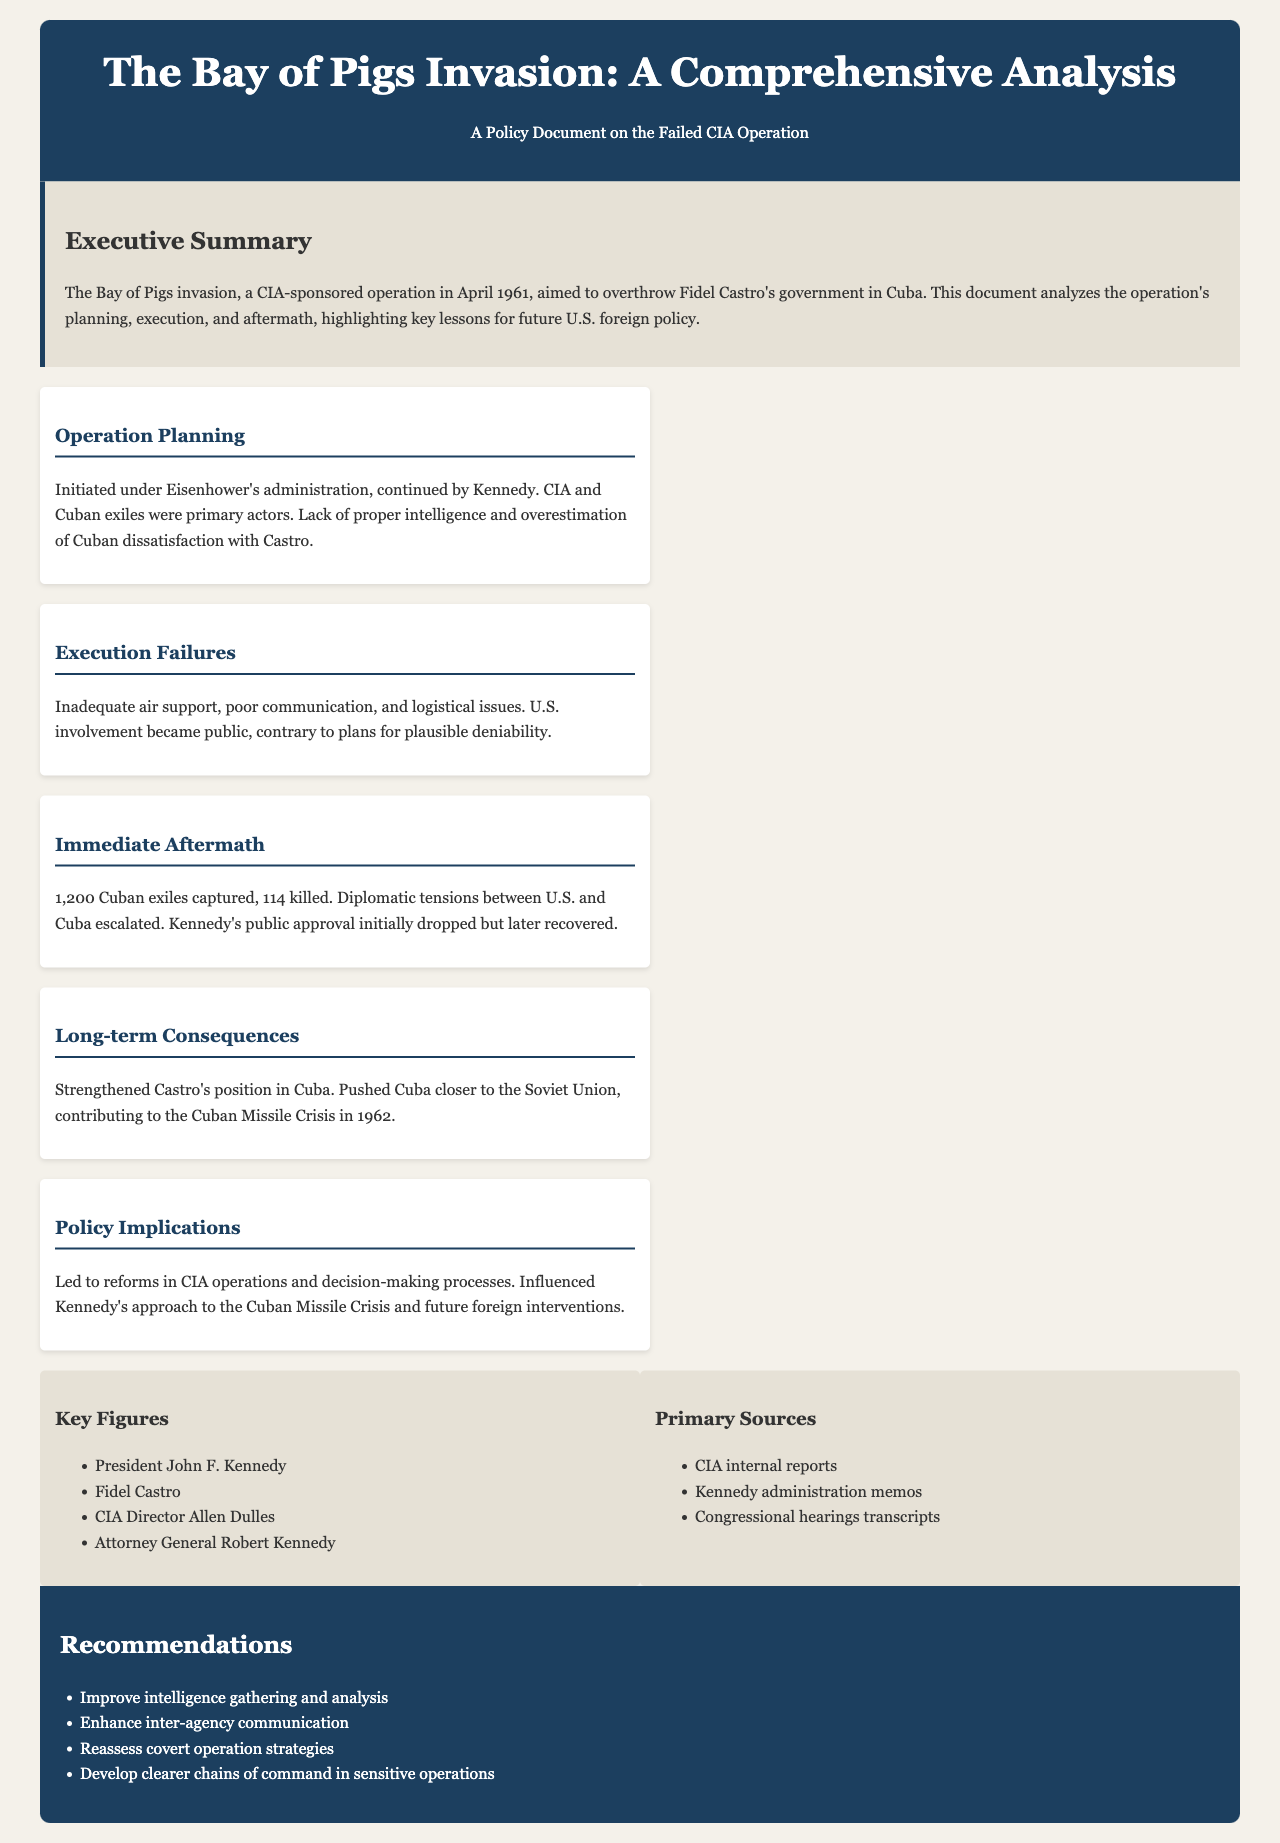What was the objective of the Bay of Pigs invasion? The objective was to overthrow Fidel Castro's government in Cuba.
Answer: Overthrow Fidel Castro's government Who were the primary actors in the operation planning? The primary actors were the CIA and Cuban exiles.
Answer: CIA and Cuban exiles What was the initial fate of the Cuban exiles who participated in the invasion? The fate of the Cuban exiles included 1,200 captured and 114 killed.
Answer: 1,200 captured, 114 killed What significant diplomatic outcome followed the invasion? The significant outcome was escalation of diplomatic tensions between U.S. and Cuba.
Answer: Escalation of diplomatic tensions Which year did the Bay of Pigs invasion take place? The year was April 1961.
Answer: April 1961 What was one of the long-term consequences of the operation? One consequence was strengthening Castro's position in Cuba.
Answer: Strengthening Castro's position Which document section discusses key lessons for future U.S. foreign policy? The section discussing key lessons is "Policy Implications."
Answer: Policy Implications Name one of the recommendations provided in the document. One recommendation is to improve intelligence gathering and analysis.
Answer: Improve intelligence gathering Who was the President of the United States during the Bay of Pigs invasion? The President was John F. Kennedy.
Answer: John F. Kennedy 